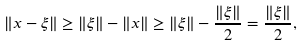Convert formula to latex. <formula><loc_0><loc_0><loc_500><loc_500>\| x - \xi \| \geq \| \xi \| - \| x \| \geq \| \xi \| - \frac { \| \xi \| } { 2 } = \frac { \| \xi \| } { 2 } ,</formula> 